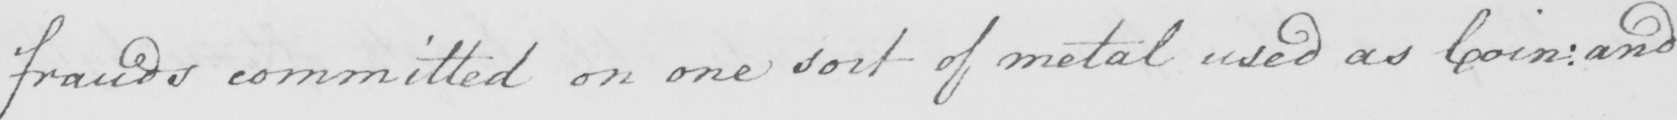Please provide the text content of this handwritten line. frauds committed on one sort of metal used as Coin :  and 